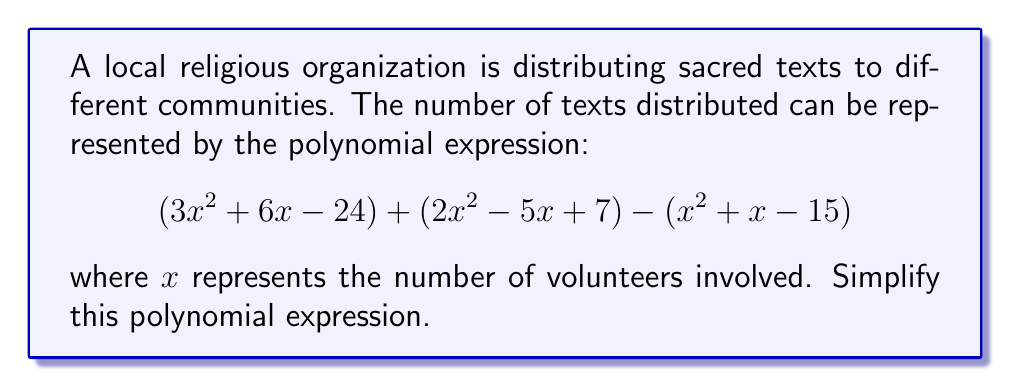Provide a solution to this math problem. To simplify this polynomial expression, we need to combine like terms. Let's approach this step-by-step:

1) First, let's identify the like terms:
   - $x^2$ terms: $3x^2$, $2x^2$, and $-x^2$
   - $x$ terms: $6x$, $-5x$, and $-x$
   - Constant terms: $-24$, $7$, and $15$

2) Now, let's combine these like terms:

   For $x^2$ terms:
   $3x^2 + 2x^2 - x^2 = 4x^2$

   For $x$ terms:
   $6x - 5x - x = 0$

   For constant terms:
   $-24 + 7 + 15 = -2$

3) Now we can write our simplified polynomial:

   $4x^2 + 0x - 2$

4) Since the coefficient of $x$ is zero, we can omit this term, giving us our final simplified expression:

   $4x^2 - 2$

This simplified polynomial represents the total number of texts distributed as a function of the number of volunteers involved.
Answer: $4x^2 - 2$ 